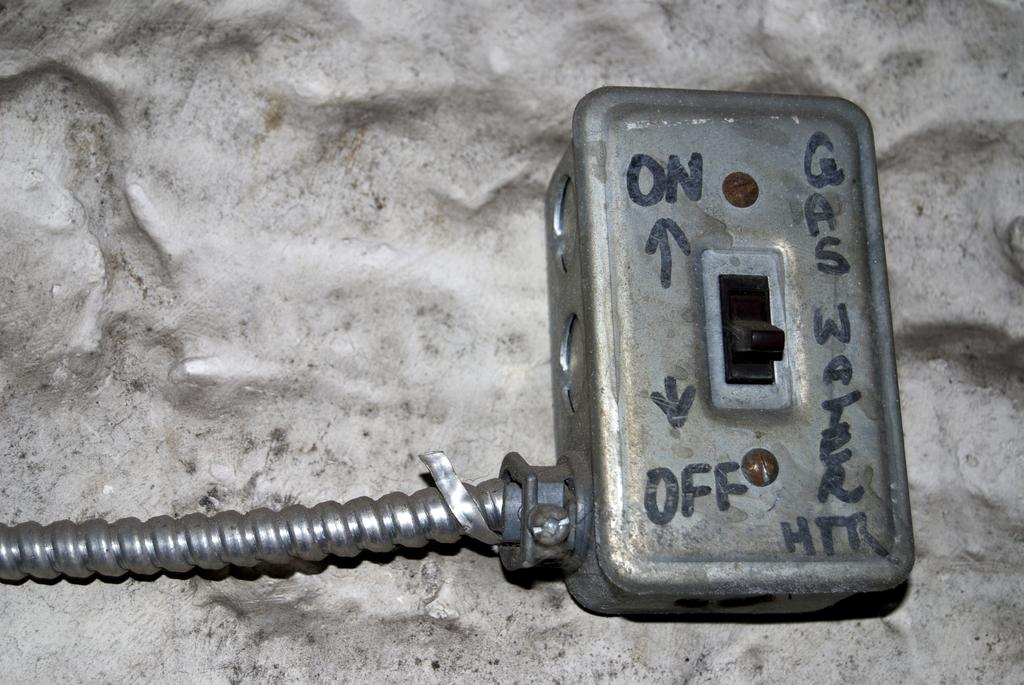<image>
Offer a succinct explanation of the picture presented. A closeup of a gas and water on and off switch. 